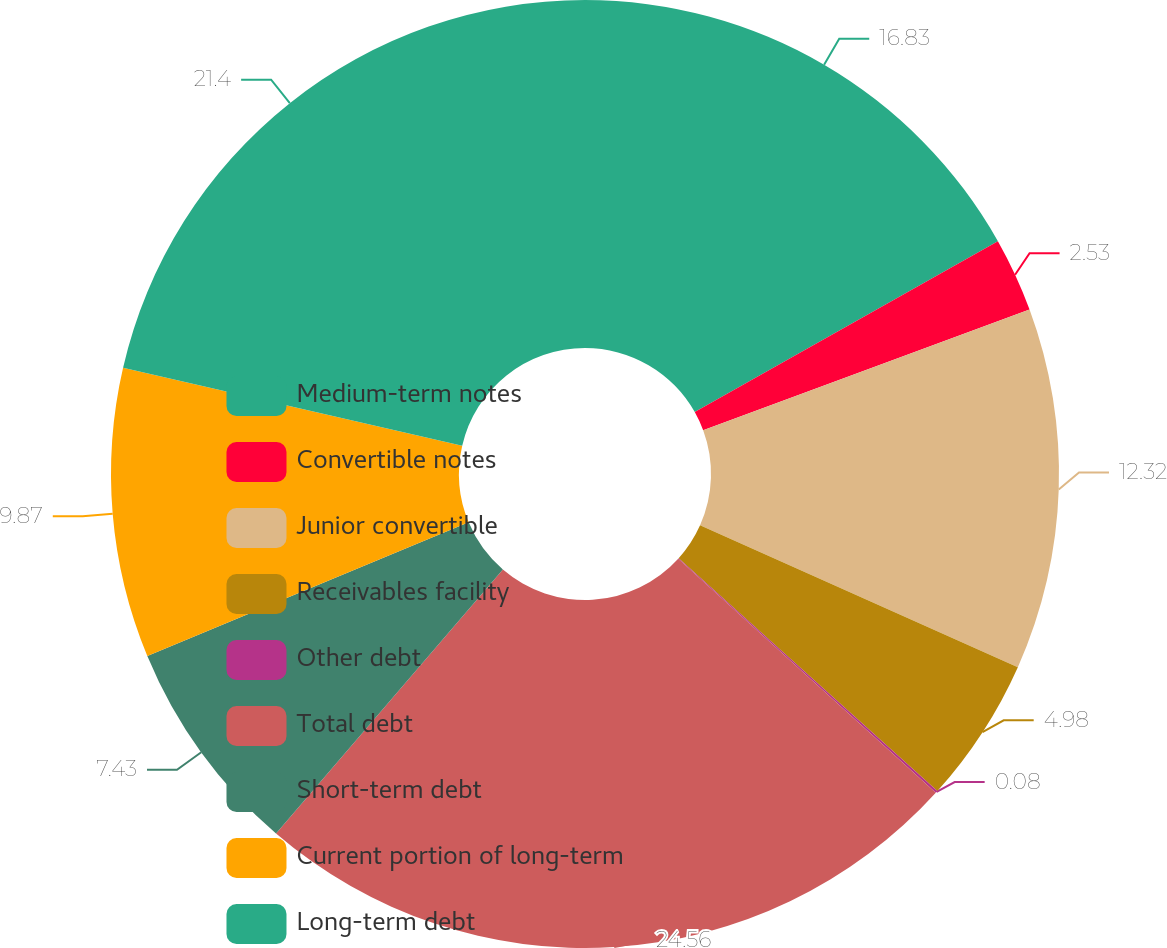<chart> <loc_0><loc_0><loc_500><loc_500><pie_chart><fcel>Medium-term notes<fcel>Convertible notes<fcel>Junior convertible<fcel>Receivables facility<fcel>Other debt<fcel>Total debt<fcel>Short-term debt<fcel>Current portion of long-term<fcel>Long-term debt<nl><fcel>16.83%<fcel>2.53%<fcel>12.32%<fcel>4.98%<fcel>0.08%<fcel>24.56%<fcel>7.43%<fcel>9.87%<fcel>21.4%<nl></chart> 